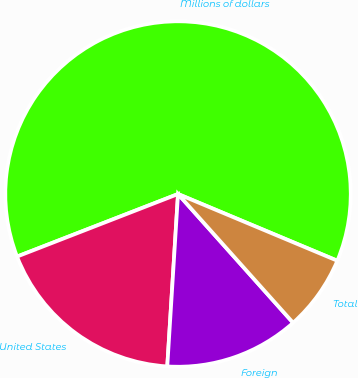Convert chart. <chart><loc_0><loc_0><loc_500><loc_500><pie_chart><fcel>Millions of dollars<fcel>United States<fcel>Foreign<fcel>Total<nl><fcel>62.21%<fcel>18.11%<fcel>12.6%<fcel>7.08%<nl></chart> 